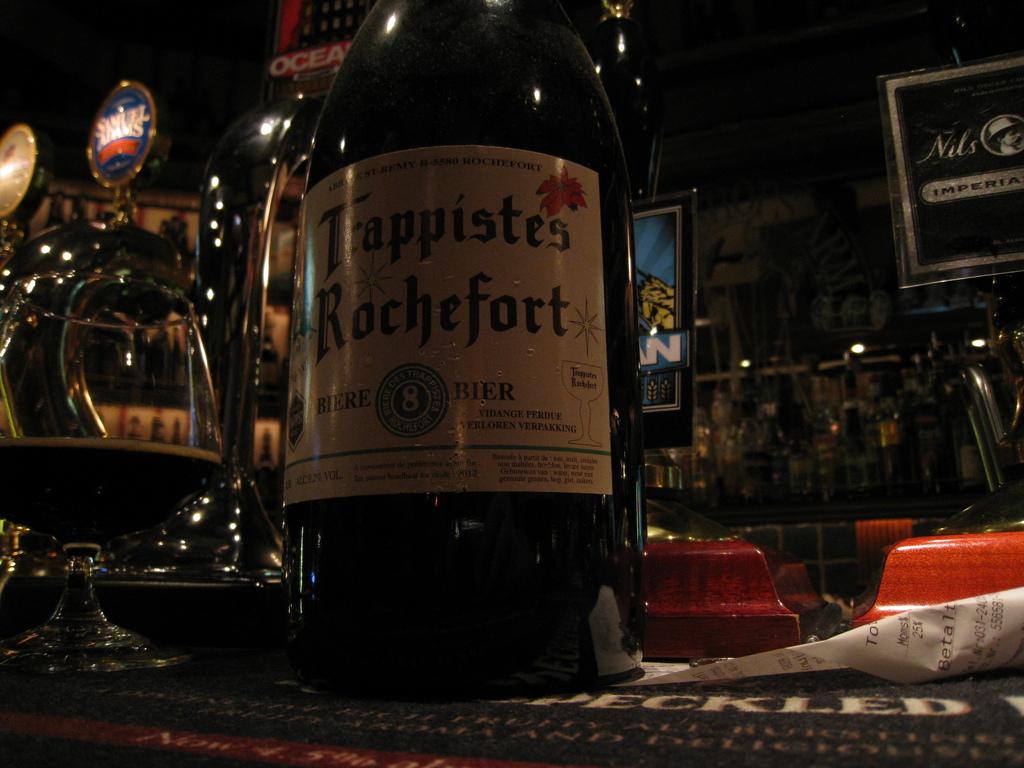Who makes that alcohol?
Provide a short and direct response. Trappistes rochefort. What kind of alcoholic beverage is in the bottle?
Give a very brief answer. Beer. 